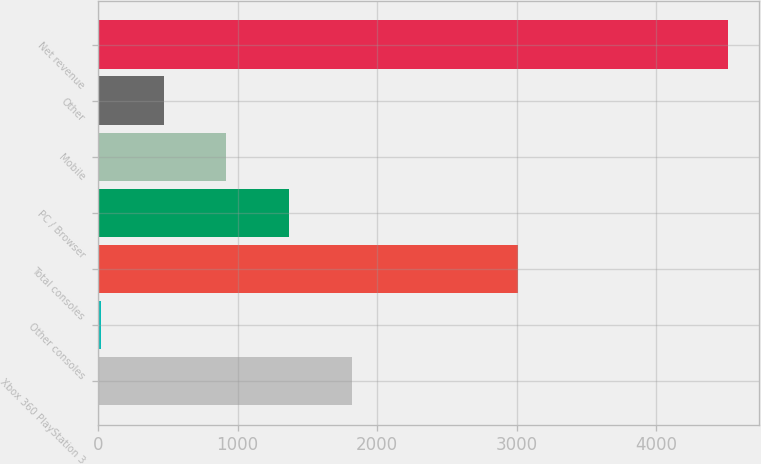<chart> <loc_0><loc_0><loc_500><loc_500><bar_chart><fcel>Xbox 360 PlayStation 3<fcel>Other consoles<fcel>Total consoles<fcel>PC / Browser<fcel>Mobile<fcel>Other<fcel>Net revenue<nl><fcel>1818.6<fcel>21<fcel>3011<fcel>1369.2<fcel>919.8<fcel>470.4<fcel>4515<nl></chart> 